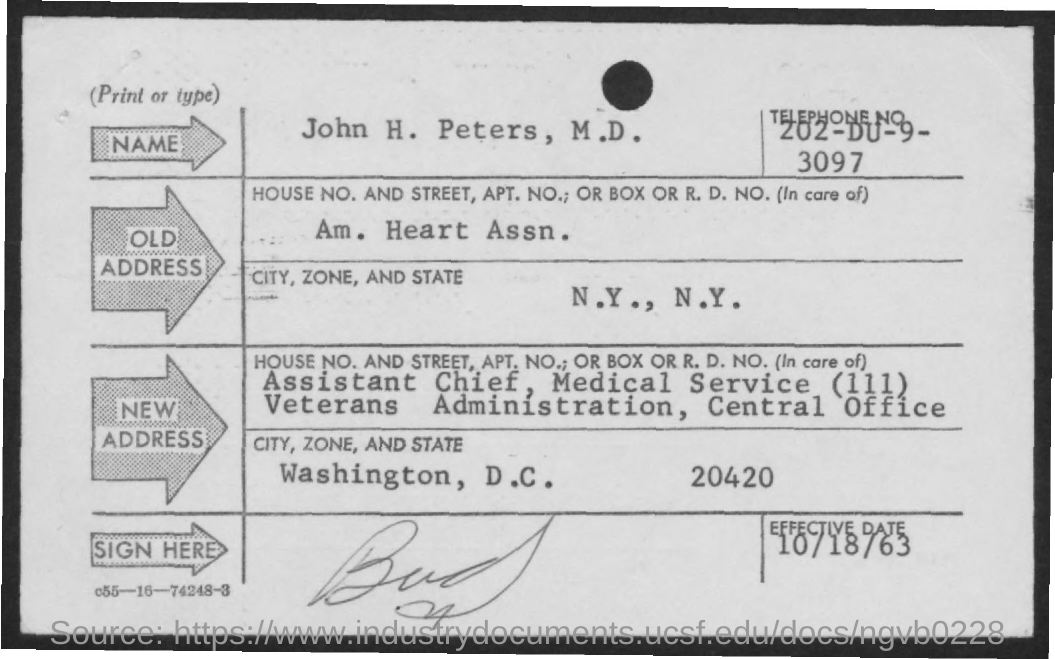Give some essential details in this illustration. The telephone number provided in the form is 202-DU-9-3097. What is the effective date, specifically 10/18/63? 